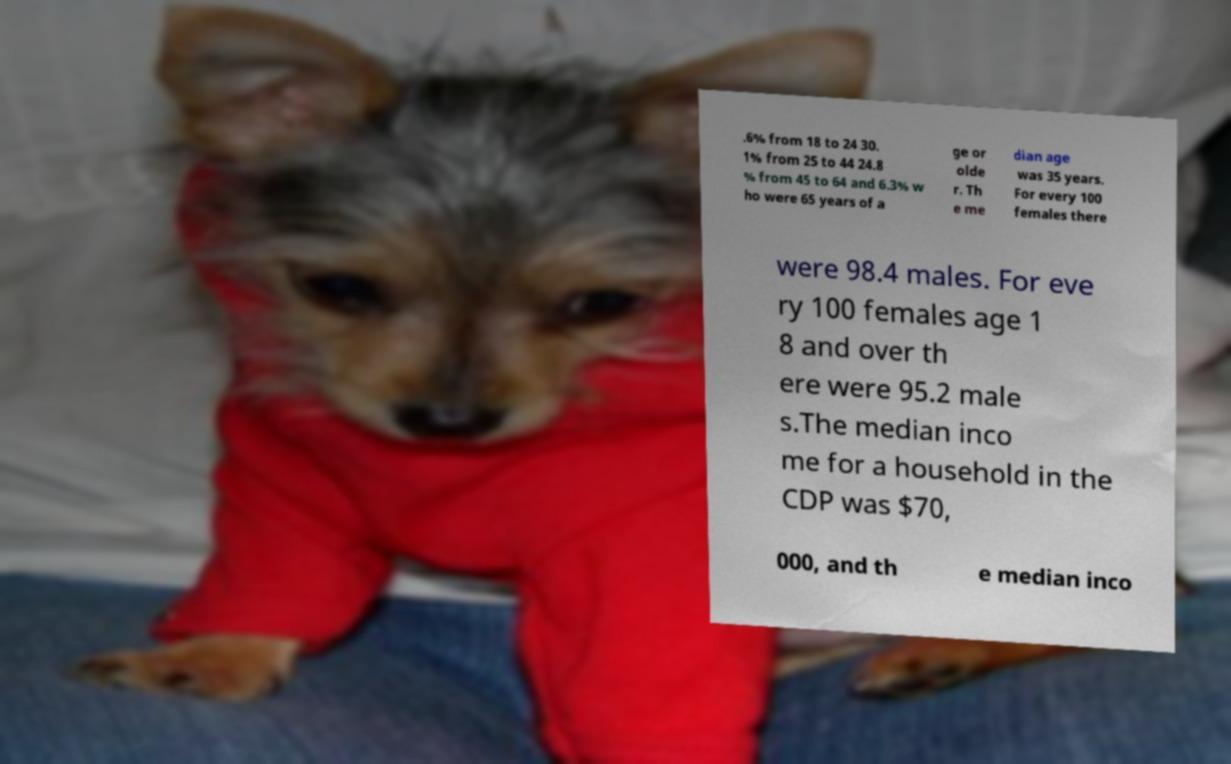Could you assist in decoding the text presented in this image and type it out clearly? .6% from 18 to 24 30. 1% from 25 to 44 24.8 % from 45 to 64 and 6.3% w ho were 65 years of a ge or olde r. Th e me dian age was 35 years. For every 100 females there were 98.4 males. For eve ry 100 females age 1 8 and over th ere were 95.2 male s.The median inco me for a household in the CDP was $70, 000, and th e median inco 